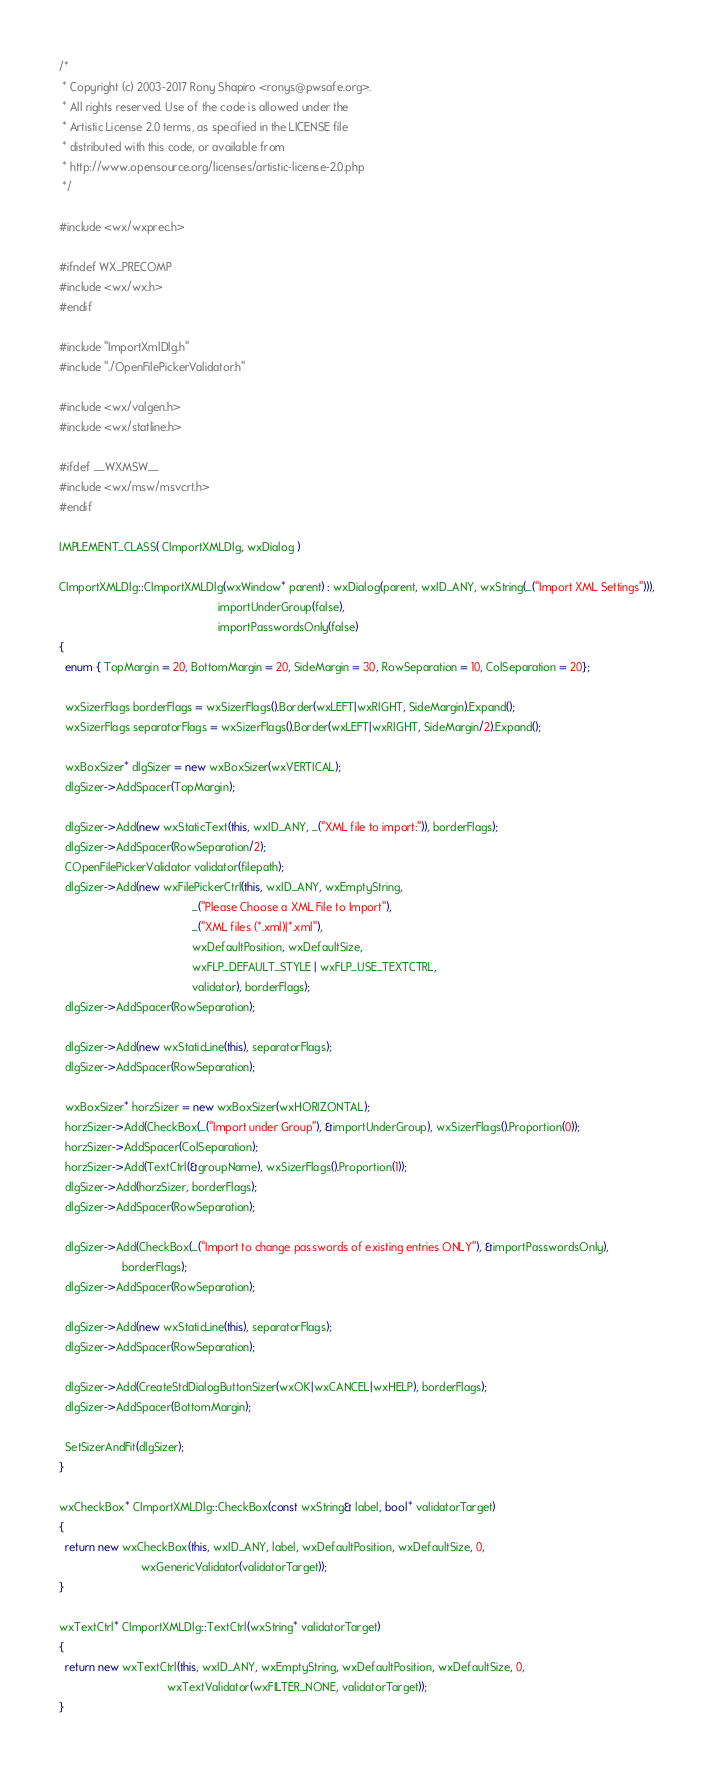<code> <loc_0><loc_0><loc_500><loc_500><_C++_>/*
 * Copyright (c) 2003-2017 Rony Shapiro <ronys@pwsafe.org>.
 * All rights reserved. Use of the code is allowed under the
 * Artistic License 2.0 terms, as specified in the LICENSE file
 * distributed with this code, or available from
 * http://www.opensource.org/licenses/artistic-license-2.0.php
 */

#include <wx/wxprec.h>

#ifndef WX_PRECOMP
#include <wx/wx.h>
#endif

#include "ImportXmlDlg.h"
#include "./OpenFilePickerValidator.h"

#include <wx/valgen.h>
#include <wx/statline.h>

#ifdef __WXMSW__
#include <wx/msw/msvcrt.h>
#endif

IMPLEMENT_CLASS( CImportXMLDlg, wxDialog )

CImportXMLDlg::CImportXMLDlg(wxWindow* parent) : wxDialog(parent, wxID_ANY, wxString(_("Import XML Settings"))),
                                                  importUnderGroup(false), 
                                                  importPasswordsOnly(false)
{
  enum { TopMargin = 20, BottomMargin = 20, SideMargin = 30, RowSeparation = 10, ColSeparation = 20};
  
  wxSizerFlags borderFlags = wxSizerFlags().Border(wxLEFT|wxRIGHT, SideMargin).Expand();
  wxSizerFlags separatorFlags = wxSizerFlags().Border(wxLEFT|wxRIGHT, SideMargin/2).Expand();
  
  wxBoxSizer* dlgSizer = new wxBoxSizer(wxVERTICAL);
  dlgSizer->AddSpacer(TopMargin);

  dlgSizer->Add(new wxStaticText(this, wxID_ANY, _("XML file to import:")), borderFlags);
  dlgSizer->AddSpacer(RowSeparation/2);
  COpenFilePickerValidator validator(filepath);
  dlgSizer->Add(new wxFilePickerCtrl(this, wxID_ANY, wxEmptyString, 
                                          _("Please Choose a XML File to Import"), 
                                          _("XML files (*.xml)|*.xml"), 
                                          wxDefaultPosition, wxDefaultSize, 
                                          wxFLP_DEFAULT_STYLE | wxFLP_USE_TEXTCTRL, 
                                          validator), borderFlags);
  dlgSizer->AddSpacer(RowSeparation);

  dlgSizer->Add(new wxStaticLine(this), separatorFlags);
  dlgSizer->AddSpacer(RowSeparation);
  
  wxBoxSizer* horzSizer = new wxBoxSizer(wxHORIZONTAL);
  horzSizer->Add(CheckBox(_("Import under Group"), &importUnderGroup), wxSizerFlags().Proportion(0));
  horzSizer->AddSpacer(ColSeparation);
  horzSizer->Add(TextCtrl(&groupName), wxSizerFlags().Proportion(1));
  dlgSizer->Add(horzSizer, borderFlags);
  dlgSizer->AddSpacer(RowSeparation);
  
  dlgSizer->Add(CheckBox(_("Import to change passwords of existing entries ONLY"), &importPasswordsOnly),
                    borderFlags);
  dlgSizer->AddSpacer(RowSeparation);
  
  dlgSizer->Add(new wxStaticLine(this), separatorFlags);
  dlgSizer->AddSpacer(RowSeparation);
  
  dlgSizer->Add(CreateStdDialogButtonSizer(wxOK|wxCANCEL|wxHELP), borderFlags);
  dlgSizer->AddSpacer(BottomMargin);
  
  SetSizerAndFit(dlgSizer);
}

wxCheckBox* CImportXMLDlg::CheckBox(const wxString& label, bool* validatorTarget)
{
  return new wxCheckBox(this, wxID_ANY, label, wxDefaultPosition, wxDefaultSize, 0,
                          wxGenericValidator(validatorTarget));
}

wxTextCtrl* CImportXMLDlg::TextCtrl(wxString* validatorTarget)
{
  return new wxTextCtrl(this, wxID_ANY, wxEmptyString, wxDefaultPosition, wxDefaultSize, 0, 
                                  wxTextValidator(wxFILTER_NONE, validatorTarget));
}
</code> 